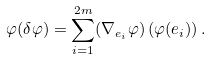Convert formula to latex. <formula><loc_0><loc_0><loc_500><loc_500>\varphi ( \delta \varphi ) = \sum _ { i = 1 } ^ { 2 m } ( \nabla _ { e _ { i } } \varphi ) \left ( \varphi ( e _ { i } ) \right ) .</formula> 